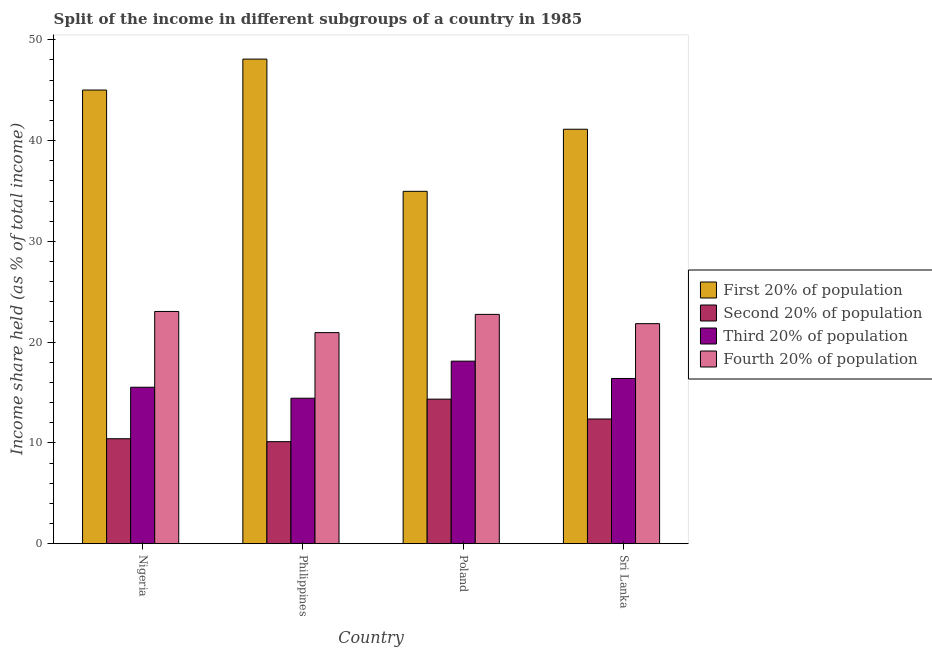Are the number of bars per tick equal to the number of legend labels?
Provide a short and direct response. Yes. Are the number of bars on each tick of the X-axis equal?
Offer a very short reply. Yes. How many bars are there on the 2nd tick from the left?
Offer a very short reply. 4. How many bars are there on the 4th tick from the right?
Your response must be concise. 4. What is the label of the 4th group of bars from the left?
Your response must be concise. Sri Lanka. What is the share of the income held by second 20% of the population in Sri Lanka?
Offer a terse response. 12.37. Across all countries, what is the maximum share of the income held by second 20% of the population?
Your answer should be very brief. 14.34. Across all countries, what is the minimum share of the income held by fourth 20% of the population?
Your answer should be very brief. 20.94. In which country was the share of the income held by first 20% of the population minimum?
Keep it short and to the point. Poland. What is the total share of the income held by second 20% of the population in the graph?
Provide a succinct answer. 47.24. What is the difference between the share of the income held by second 20% of the population in Nigeria and that in Philippines?
Your response must be concise. 0.29. What is the difference between the share of the income held by third 20% of the population in Poland and the share of the income held by second 20% of the population in Sri Lanka?
Give a very brief answer. 5.74. What is the average share of the income held by first 20% of the population per country?
Ensure brevity in your answer.  42.29. What is the difference between the share of the income held by third 20% of the population and share of the income held by second 20% of the population in Philippines?
Your answer should be very brief. 4.31. In how many countries, is the share of the income held by first 20% of the population greater than 18 %?
Make the answer very short. 4. What is the ratio of the share of the income held by fourth 20% of the population in Philippines to that in Sri Lanka?
Provide a short and direct response. 0.96. Is the share of the income held by first 20% of the population in Nigeria less than that in Poland?
Your answer should be compact. No. What is the difference between the highest and the second highest share of the income held by first 20% of the population?
Ensure brevity in your answer.  3.07. What is the difference between the highest and the lowest share of the income held by third 20% of the population?
Offer a terse response. 3.68. Is the sum of the share of the income held by first 20% of the population in Nigeria and Philippines greater than the maximum share of the income held by fourth 20% of the population across all countries?
Offer a very short reply. Yes. Is it the case that in every country, the sum of the share of the income held by second 20% of the population and share of the income held by fourth 20% of the population is greater than the sum of share of the income held by first 20% of the population and share of the income held by third 20% of the population?
Your response must be concise. No. What does the 4th bar from the left in Nigeria represents?
Keep it short and to the point. Fourth 20% of population. What does the 4th bar from the right in Poland represents?
Keep it short and to the point. First 20% of population. Is it the case that in every country, the sum of the share of the income held by first 20% of the population and share of the income held by second 20% of the population is greater than the share of the income held by third 20% of the population?
Your response must be concise. Yes. How many bars are there?
Your answer should be compact. 16. Are all the bars in the graph horizontal?
Give a very brief answer. No. What is the difference between two consecutive major ticks on the Y-axis?
Provide a short and direct response. 10. Does the graph contain any zero values?
Your answer should be compact. No. Does the graph contain grids?
Your answer should be compact. No. Where does the legend appear in the graph?
Offer a terse response. Center right. How are the legend labels stacked?
Give a very brief answer. Vertical. What is the title of the graph?
Make the answer very short. Split of the income in different subgroups of a country in 1985. What is the label or title of the X-axis?
Keep it short and to the point. Country. What is the label or title of the Y-axis?
Provide a succinct answer. Income share held (as % of total income). What is the Income share held (as % of total income) of First 20% of population in Nigeria?
Your response must be concise. 45.01. What is the Income share held (as % of total income) in Second 20% of population in Nigeria?
Provide a succinct answer. 10.41. What is the Income share held (as % of total income) in Third 20% of population in Nigeria?
Your answer should be compact. 15.52. What is the Income share held (as % of total income) in Fourth 20% of population in Nigeria?
Keep it short and to the point. 23.04. What is the Income share held (as % of total income) of First 20% of population in Philippines?
Keep it short and to the point. 48.08. What is the Income share held (as % of total income) of Second 20% of population in Philippines?
Give a very brief answer. 10.12. What is the Income share held (as % of total income) of Third 20% of population in Philippines?
Ensure brevity in your answer.  14.43. What is the Income share held (as % of total income) in Fourth 20% of population in Philippines?
Make the answer very short. 20.94. What is the Income share held (as % of total income) in First 20% of population in Poland?
Ensure brevity in your answer.  34.96. What is the Income share held (as % of total income) of Second 20% of population in Poland?
Make the answer very short. 14.34. What is the Income share held (as % of total income) in Third 20% of population in Poland?
Give a very brief answer. 18.11. What is the Income share held (as % of total income) of Fourth 20% of population in Poland?
Give a very brief answer. 22.75. What is the Income share held (as % of total income) in First 20% of population in Sri Lanka?
Ensure brevity in your answer.  41.12. What is the Income share held (as % of total income) in Second 20% of population in Sri Lanka?
Provide a short and direct response. 12.37. What is the Income share held (as % of total income) of Third 20% of population in Sri Lanka?
Keep it short and to the point. 16.39. What is the Income share held (as % of total income) in Fourth 20% of population in Sri Lanka?
Ensure brevity in your answer.  21.83. Across all countries, what is the maximum Income share held (as % of total income) of First 20% of population?
Ensure brevity in your answer.  48.08. Across all countries, what is the maximum Income share held (as % of total income) of Second 20% of population?
Give a very brief answer. 14.34. Across all countries, what is the maximum Income share held (as % of total income) of Third 20% of population?
Offer a very short reply. 18.11. Across all countries, what is the maximum Income share held (as % of total income) in Fourth 20% of population?
Make the answer very short. 23.04. Across all countries, what is the minimum Income share held (as % of total income) in First 20% of population?
Your answer should be compact. 34.96. Across all countries, what is the minimum Income share held (as % of total income) of Second 20% of population?
Offer a terse response. 10.12. Across all countries, what is the minimum Income share held (as % of total income) of Third 20% of population?
Your answer should be very brief. 14.43. Across all countries, what is the minimum Income share held (as % of total income) of Fourth 20% of population?
Offer a very short reply. 20.94. What is the total Income share held (as % of total income) of First 20% of population in the graph?
Your answer should be compact. 169.17. What is the total Income share held (as % of total income) of Second 20% of population in the graph?
Your answer should be very brief. 47.24. What is the total Income share held (as % of total income) in Third 20% of population in the graph?
Your answer should be very brief. 64.45. What is the total Income share held (as % of total income) in Fourth 20% of population in the graph?
Your answer should be very brief. 88.56. What is the difference between the Income share held (as % of total income) of First 20% of population in Nigeria and that in Philippines?
Give a very brief answer. -3.07. What is the difference between the Income share held (as % of total income) of Second 20% of population in Nigeria and that in Philippines?
Give a very brief answer. 0.29. What is the difference between the Income share held (as % of total income) in Third 20% of population in Nigeria and that in Philippines?
Your response must be concise. 1.09. What is the difference between the Income share held (as % of total income) of First 20% of population in Nigeria and that in Poland?
Provide a succinct answer. 10.05. What is the difference between the Income share held (as % of total income) in Second 20% of population in Nigeria and that in Poland?
Offer a very short reply. -3.93. What is the difference between the Income share held (as % of total income) in Third 20% of population in Nigeria and that in Poland?
Your response must be concise. -2.59. What is the difference between the Income share held (as % of total income) in Fourth 20% of population in Nigeria and that in Poland?
Offer a very short reply. 0.29. What is the difference between the Income share held (as % of total income) of First 20% of population in Nigeria and that in Sri Lanka?
Provide a succinct answer. 3.89. What is the difference between the Income share held (as % of total income) in Second 20% of population in Nigeria and that in Sri Lanka?
Offer a terse response. -1.96. What is the difference between the Income share held (as % of total income) of Third 20% of population in Nigeria and that in Sri Lanka?
Your answer should be very brief. -0.87. What is the difference between the Income share held (as % of total income) in Fourth 20% of population in Nigeria and that in Sri Lanka?
Make the answer very short. 1.21. What is the difference between the Income share held (as % of total income) of First 20% of population in Philippines and that in Poland?
Your answer should be very brief. 13.12. What is the difference between the Income share held (as % of total income) of Second 20% of population in Philippines and that in Poland?
Provide a short and direct response. -4.22. What is the difference between the Income share held (as % of total income) of Third 20% of population in Philippines and that in Poland?
Your answer should be very brief. -3.68. What is the difference between the Income share held (as % of total income) of Fourth 20% of population in Philippines and that in Poland?
Offer a very short reply. -1.81. What is the difference between the Income share held (as % of total income) of First 20% of population in Philippines and that in Sri Lanka?
Ensure brevity in your answer.  6.96. What is the difference between the Income share held (as % of total income) of Second 20% of population in Philippines and that in Sri Lanka?
Keep it short and to the point. -2.25. What is the difference between the Income share held (as % of total income) in Third 20% of population in Philippines and that in Sri Lanka?
Your answer should be very brief. -1.96. What is the difference between the Income share held (as % of total income) of Fourth 20% of population in Philippines and that in Sri Lanka?
Offer a very short reply. -0.89. What is the difference between the Income share held (as % of total income) in First 20% of population in Poland and that in Sri Lanka?
Provide a succinct answer. -6.16. What is the difference between the Income share held (as % of total income) of Second 20% of population in Poland and that in Sri Lanka?
Make the answer very short. 1.97. What is the difference between the Income share held (as % of total income) of Third 20% of population in Poland and that in Sri Lanka?
Ensure brevity in your answer.  1.72. What is the difference between the Income share held (as % of total income) of Fourth 20% of population in Poland and that in Sri Lanka?
Provide a short and direct response. 0.92. What is the difference between the Income share held (as % of total income) of First 20% of population in Nigeria and the Income share held (as % of total income) of Second 20% of population in Philippines?
Provide a short and direct response. 34.89. What is the difference between the Income share held (as % of total income) of First 20% of population in Nigeria and the Income share held (as % of total income) of Third 20% of population in Philippines?
Provide a short and direct response. 30.58. What is the difference between the Income share held (as % of total income) in First 20% of population in Nigeria and the Income share held (as % of total income) in Fourth 20% of population in Philippines?
Make the answer very short. 24.07. What is the difference between the Income share held (as % of total income) of Second 20% of population in Nigeria and the Income share held (as % of total income) of Third 20% of population in Philippines?
Give a very brief answer. -4.02. What is the difference between the Income share held (as % of total income) in Second 20% of population in Nigeria and the Income share held (as % of total income) in Fourth 20% of population in Philippines?
Offer a very short reply. -10.53. What is the difference between the Income share held (as % of total income) in Third 20% of population in Nigeria and the Income share held (as % of total income) in Fourth 20% of population in Philippines?
Keep it short and to the point. -5.42. What is the difference between the Income share held (as % of total income) of First 20% of population in Nigeria and the Income share held (as % of total income) of Second 20% of population in Poland?
Provide a short and direct response. 30.67. What is the difference between the Income share held (as % of total income) of First 20% of population in Nigeria and the Income share held (as % of total income) of Third 20% of population in Poland?
Provide a short and direct response. 26.9. What is the difference between the Income share held (as % of total income) of First 20% of population in Nigeria and the Income share held (as % of total income) of Fourth 20% of population in Poland?
Keep it short and to the point. 22.26. What is the difference between the Income share held (as % of total income) in Second 20% of population in Nigeria and the Income share held (as % of total income) in Fourth 20% of population in Poland?
Offer a very short reply. -12.34. What is the difference between the Income share held (as % of total income) in Third 20% of population in Nigeria and the Income share held (as % of total income) in Fourth 20% of population in Poland?
Offer a terse response. -7.23. What is the difference between the Income share held (as % of total income) of First 20% of population in Nigeria and the Income share held (as % of total income) of Second 20% of population in Sri Lanka?
Make the answer very short. 32.64. What is the difference between the Income share held (as % of total income) of First 20% of population in Nigeria and the Income share held (as % of total income) of Third 20% of population in Sri Lanka?
Make the answer very short. 28.62. What is the difference between the Income share held (as % of total income) of First 20% of population in Nigeria and the Income share held (as % of total income) of Fourth 20% of population in Sri Lanka?
Offer a terse response. 23.18. What is the difference between the Income share held (as % of total income) of Second 20% of population in Nigeria and the Income share held (as % of total income) of Third 20% of population in Sri Lanka?
Provide a short and direct response. -5.98. What is the difference between the Income share held (as % of total income) of Second 20% of population in Nigeria and the Income share held (as % of total income) of Fourth 20% of population in Sri Lanka?
Keep it short and to the point. -11.42. What is the difference between the Income share held (as % of total income) in Third 20% of population in Nigeria and the Income share held (as % of total income) in Fourth 20% of population in Sri Lanka?
Provide a succinct answer. -6.31. What is the difference between the Income share held (as % of total income) of First 20% of population in Philippines and the Income share held (as % of total income) of Second 20% of population in Poland?
Your answer should be compact. 33.74. What is the difference between the Income share held (as % of total income) of First 20% of population in Philippines and the Income share held (as % of total income) of Third 20% of population in Poland?
Offer a terse response. 29.97. What is the difference between the Income share held (as % of total income) of First 20% of population in Philippines and the Income share held (as % of total income) of Fourth 20% of population in Poland?
Make the answer very short. 25.33. What is the difference between the Income share held (as % of total income) in Second 20% of population in Philippines and the Income share held (as % of total income) in Third 20% of population in Poland?
Provide a succinct answer. -7.99. What is the difference between the Income share held (as % of total income) in Second 20% of population in Philippines and the Income share held (as % of total income) in Fourth 20% of population in Poland?
Provide a short and direct response. -12.63. What is the difference between the Income share held (as % of total income) of Third 20% of population in Philippines and the Income share held (as % of total income) of Fourth 20% of population in Poland?
Provide a short and direct response. -8.32. What is the difference between the Income share held (as % of total income) in First 20% of population in Philippines and the Income share held (as % of total income) in Second 20% of population in Sri Lanka?
Ensure brevity in your answer.  35.71. What is the difference between the Income share held (as % of total income) of First 20% of population in Philippines and the Income share held (as % of total income) of Third 20% of population in Sri Lanka?
Your response must be concise. 31.69. What is the difference between the Income share held (as % of total income) of First 20% of population in Philippines and the Income share held (as % of total income) of Fourth 20% of population in Sri Lanka?
Provide a short and direct response. 26.25. What is the difference between the Income share held (as % of total income) in Second 20% of population in Philippines and the Income share held (as % of total income) in Third 20% of population in Sri Lanka?
Keep it short and to the point. -6.27. What is the difference between the Income share held (as % of total income) in Second 20% of population in Philippines and the Income share held (as % of total income) in Fourth 20% of population in Sri Lanka?
Your answer should be compact. -11.71. What is the difference between the Income share held (as % of total income) of Third 20% of population in Philippines and the Income share held (as % of total income) of Fourth 20% of population in Sri Lanka?
Your answer should be very brief. -7.4. What is the difference between the Income share held (as % of total income) of First 20% of population in Poland and the Income share held (as % of total income) of Second 20% of population in Sri Lanka?
Your answer should be very brief. 22.59. What is the difference between the Income share held (as % of total income) of First 20% of population in Poland and the Income share held (as % of total income) of Third 20% of population in Sri Lanka?
Offer a very short reply. 18.57. What is the difference between the Income share held (as % of total income) of First 20% of population in Poland and the Income share held (as % of total income) of Fourth 20% of population in Sri Lanka?
Keep it short and to the point. 13.13. What is the difference between the Income share held (as % of total income) of Second 20% of population in Poland and the Income share held (as % of total income) of Third 20% of population in Sri Lanka?
Your answer should be compact. -2.05. What is the difference between the Income share held (as % of total income) in Second 20% of population in Poland and the Income share held (as % of total income) in Fourth 20% of population in Sri Lanka?
Your response must be concise. -7.49. What is the difference between the Income share held (as % of total income) of Third 20% of population in Poland and the Income share held (as % of total income) of Fourth 20% of population in Sri Lanka?
Give a very brief answer. -3.72. What is the average Income share held (as % of total income) in First 20% of population per country?
Ensure brevity in your answer.  42.29. What is the average Income share held (as % of total income) in Second 20% of population per country?
Provide a short and direct response. 11.81. What is the average Income share held (as % of total income) in Third 20% of population per country?
Your answer should be compact. 16.11. What is the average Income share held (as % of total income) in Fourth 20% of population per country?
Keep it short and to the point. 22.14. What is the difference between the Income share held (as % of total income) in First 20% of population and Income share held (as % of total income) in Second 20% of population in Nigeria?
Make the answer very short. 34.6. What is the difference between the Income share held (as % of total income) in First 20% of population and Income share held (as % of total income) in Third 20% of population in Nigeria?
Provide a short and direct response. 29.49. What is the difference between the Income share held (as % of total income) of First 20% of population and Income share held (as % of total income) of Fourth 20% of population in Nigeria?
Your answer should be very brief. 21.97. What is the difference between the Income share held (as % of total income) in Second 20% of population and Income share held (as % of total income) in Third 20% of population in Nigeria?
Your answer should be very brief. -5.11. What is the difference between the Income share held (as % of total income) in Second 20% of population and Income share held (as % of total income) in Fourth 20% of population in Nigeria?
Provide a short and direct response. -12.63. What is the difference between the Income share held (as % of total income) of Third 20% of population and Income share held (as % of total income) of Fourth 20% of population in Nigeria?
Your answer should be compact. -7.52. What is the difference between the Income share held (as % of total income) in First 20% of population and Income share held (as % of total income) in Second 20% of population in Philippines?
Offer a terse response. 37.96. What is the difference between the Income share held (as % of total income) of First 20% of population and Income share held (as % of total income) of Third 20% of population in Philippines?
Offer a very short reply. 33.65. What is the difference between the Income share held (as % of total income) in First 20% of population and Income share held (as % of total income) in Fourth 20% of population in Philippines?
Give a very brief answer. 27.14. What is the difference between the Income share held (as % of total income) in Second 20% of population and Income share held (as % of total income) in Third 20% of population in Philippines?
Give a very brief answer. -4.31. What is the difference between the Income share held (as % of total income) of Second 20% of population and Income share held (as % of total income) of Fourth 20% of population in Philippines?
Your answer should be very brief. -10.82. What is the difference between the Income share held (as % of total income) in Third 20% of population and Income share held (as % of total income) in Fourth 20% of population in Philippines?
Offer a terse response. -6.51. What is the difference between the Income share held (as % of total income) in First 20% of population and Income share held (as % of total income) in Second 20% of population in Poland?
Ensure brevity in your answer.  20.62. What is the difference between the Income share held (as % of total income) of First 20% of population and Income share held (as % of total income) of Third 20% of population in Poland?
Offer a very short reply. 16.85. What is the difference between the Income share held (as % of total income) of First 20% of population and Income share held (as % of total income) of Fourth 20% of population in Poland?
Offer a terse response. 12.21. What is the difference between the Income share held (as % of total income) of Second 20% of population and Income share held (as % of total income) of Third 20% of population in Poland?
Make the answer very short. -3.77. What is the difference between the Income share held (as % of total income) in Second 20% of population and Income share held (as % of total income) in Fourth 20% of population in Poland?
Ensure brevity in your answer.  -8.41. What is the difference between the Income share held (as % of total income) in Third 20% of population and Income share held (as % of total income) in Fourth 20% of population in Poland?
Make the answer very short. -4.64. What is the difference between the Income share held (as % of total income) of First 20% of population and Income share held (as % of total income) of Second 20% of population in Sri Lanka?
Your answer should be very brief. 28.75. What is the difference between the Income share held (as % of total income) in First 20% of population and Income share held (as % of total income) in Third 20% of population in Sri Lanka?
Make the answer very short. 24.73. What is the difference between the Income share held (as % of total income) in First 20% of population and Income share held (as % of total income) in Fourth 20% of population in Sri Lanka?
Keep it short and to the point. 19.29. What is the difference between the Income share held (as % of total income) of Second 20% of population and Income share held (as % of total income) of Third 20% of population in Sri Lanka?
Your answer should be compact. -4.02. What is the difference between the Income share held (as % of total income) of Second 20% of population and Income share held (as % of total income) of Fourth 20% of population in Sri Lanka?
Ensure brevity in your answer.  -9.46. What is the difference between the Income share held (as % of total income) in Third 20% of population and Income share held (as % of total income) in Fourth 20% of population in Sri Lanka?
Your answer should be compact. -5.44. What is the ratio of the Income share held (as % of total income) in First 20% of population in Nigeria to that in Philippines?
Offer a very short reply. 0.94. What is the ratio of the Income share held (as % of total income) in Second 20% of population in Nigeria to that in Philippines?
Keep it short and to the point. 1.03. What is the ratio of the Income share held (as % of total income) in Third 20% of population in Nigeria to that in Philippines?
Offer a terse response. 1.08. What is the ratio of the Income share held (as % of total income) in Fourth 20% of population in Nigeria to that in Philippines?
Your response must be concise. 1.1. What is the ratio of the Income share held (as % of total income) of First 20% of population in Nigeria to that in Poland?
Your answer should be compact. 1.29. What is the ratio of the Income share held (as % of total income) of Second 20% of population in Nigeria to that in Poland?
Keep it short and to the point. 0.73. What is the ratio of the Income share held (as % of total income) of Third 20% of population in Nigeria to that in Poland?
Provide a short and direct response. 0.86. What is the ratio of the Income share held (as % of total income) of Fourth 20% of population in Nigeria to that in Poland?
Offer a terse response. 1.01. What is the ratio of the Income share held (as % of total income) in First 20% of population in Nigeria to that in Sri Lanka?
Offer a terse response. 1.09. What is the ratio of the Income share held (as % of total income) of Second 20% of population in Nigeria to that in Sri Lanka?
Keep it short and to the point. 0.84. What is the ratio of the Income share held (as % of total income) of Third 20% of population in Nigeria to that in Sri Lanka?
Offer a terse response. 0.95. What is the ratio of the Income share held (as % of total income) in Fourth 20% of population in Nigeria to that in Sri Lanka?
Make the answer very short. 1.06. What is the ratio of the Income share held (as % of total income) of First 20% of population in Philippines to that in Poland?
Provide a short and direct response. 1.38. What is the ratio of the Income share held (as % of total income) in Second 20% of population in Philippines to that in Poland?
Give a very brief answer. 0.71. What is the ratio of the Income share held (as % of total income) of Third 20% of population in Philippines to that in Poland?
Your answer should be very brief. 0.8. What is the ratio of the Income share held (as % of total income) of Fourth 20% of population in Philippines to that in Poland?
Provide a short and direct response. 0.92. What is the ratio of the Income share held (as % of total income) of First 20% of population in Philippines to that in Sri Lanka?
Your answer should be compact. 1.17. What is the ratio of the Income share held (as % of total income) in Second 20% of population in Philippines to that in Sri Lanka?
Your response must be concise. 0.82. What is the ratio of the Income share held (as % of total income) in Third 20% of population in Philippines to that in Sri Lanka?
Offer a terse response. 0.88. What is the ratio of the Income share held (as % of total income) of Fourth 20% of population in Philippines to that in Sri Lanka?
Offer a very short reply. 0.96. What is the ratio of the Income share held (as % of total income) in First 20% of population in Poland to that in Sri Lanka?
Provide a short and direct response. 0.85. What is the ratio of the Income share held (as % of total income) of Second 20% of population in Poland to that in Sri Lanka?
Offer a terse response. 1.16. What is the ratio of the Income share held (as % of total income) in Third 20% of population in Poland to that in Sri Lanka?
Give a very brief answer. 1.1. What is the ratio of the Income share held (as % of total income) in Fourth 20% of population in Poland to that in Sri Lanka?
Provide a short and direct response. 1.04. What is the difference between the highest and the second highest Income share held (as % of total income) in First 20% of population?
Offer a terse response. 3.07. What is the difference between the highest and the second highest Income share held (as % of total income) in Second 20% of population?
Offer a terse response. 1.97. What is the difference between the highest and the second highest Income share held (as % of total income) of Third 20% of population?
Ensure brevity in your answer.  1.72. What is the difference between the highest and the second highest Income share held (as % of total income) of Fourth 20% of population?
Your answer should be compact. 0.29. What is the difference between the highest and the lowest Income share held (as % of total income) in First 20% of population?
Provide a short and direct response. 13.12. What is the difference between the highest and the lowest Income share held (as % of total income) in Second 20% of population?
Provide a succinct answer. 4.22. What is the difference between the highest and the lowest Income share held (as % of total income) in Third 20% of population?
Provide a short and direct response. 3.68. 